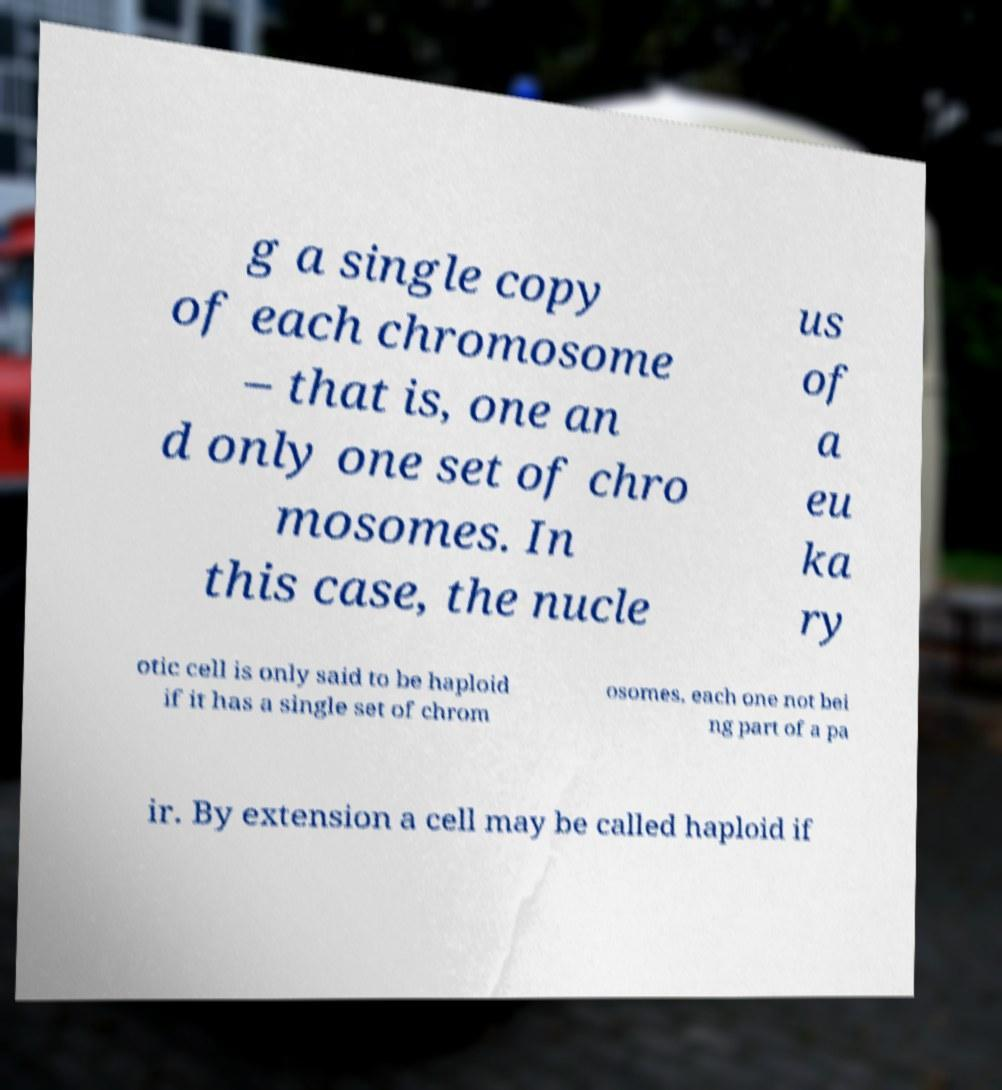Can you read and provide the text displayed in the image?This photo seems to have some interesting text. Can you extract and type it out for me? g a single copy of each chromosome – that is, one an d only one set of chro mosomes. In this case, the nucle us of a eu ka ry otic cell is only said to be haploid if it has a single set of chrom osomes, each one not bei ng part of a pa ir. By extension a cell may be called haploid if 